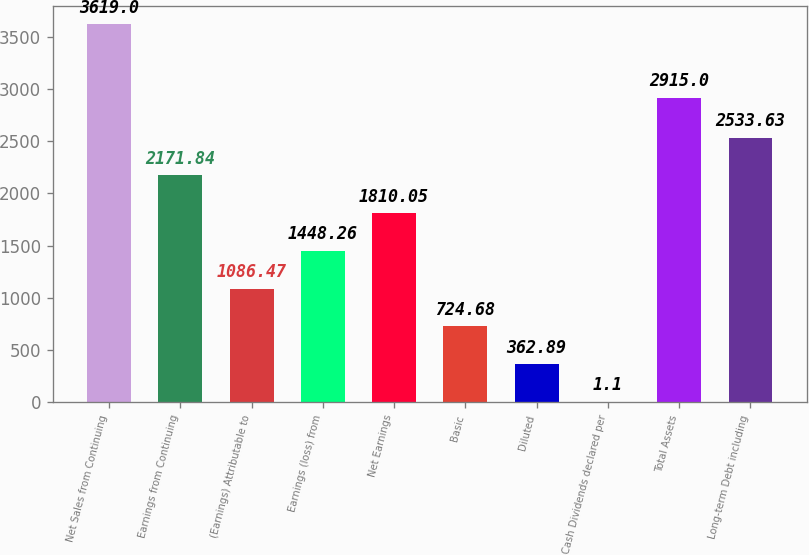Convert chart. <chart><loc_0><loc_0><loc_500><loc_500><bar_chart><fcel>Net Sales from Continuing<fcel>Earnings from Continuing<fcel>(Earnings) Attributable to<fcel>Earnings (loss) from<fcel>Net Earnings<fcel>Basic<fcel>Diluted<fcel>Cash Dividends declared per<fcel>Total Assets<fcel>Long-term Debt including<nl><fcel>3619<fcel>2171.84<fcel>1086.47<fcel>1448.26<fcel>1810.05<fcel>724.68<fcel>362.89<fcel>1.1<fcel>2915<fcel>2533.63<nl></chart> 